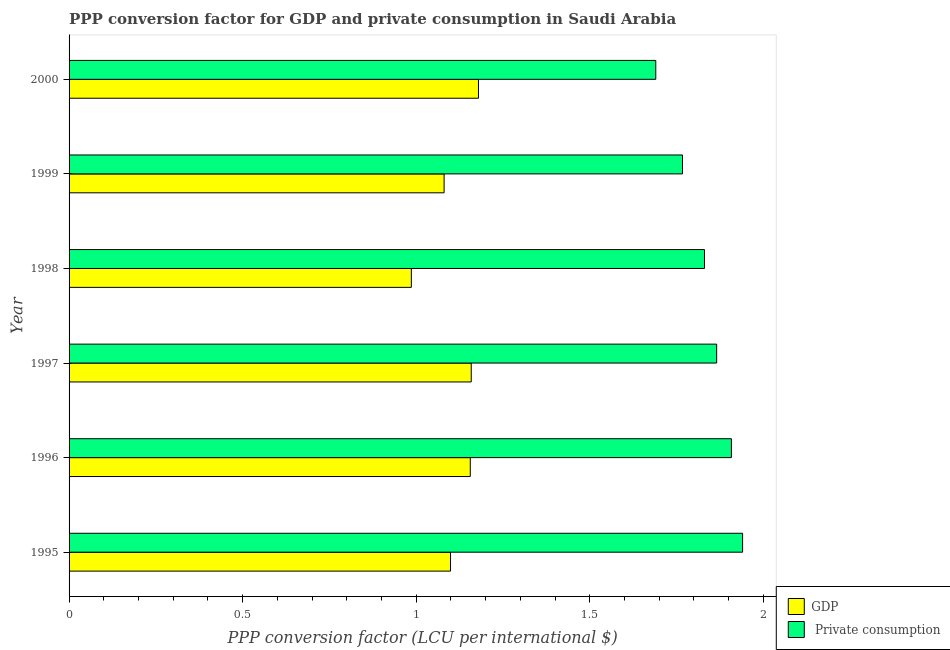How many different coloured bars are there?
Your response must be concise. 2. How many groups of bars are there?
Ensure brevity in your answer.  6. How many bars are there on the 1st tick from the bottom?
Offer a terse response. 2. What is the label of the 3rd group of bars from the top?
Offer a terse response. 1998. What is the ppp conversion factor for gdp in 1999?
Your response must be concise. 1.08. Across all years, what is the maximum ppp conversion factor for private consumption?
Make the answer very short. 1.94. Across all years, what is the minimum ppp conversion factor for gdp?
Provide a short and direct response. 0.99. What is the total ppp conversion factor for gdp in the graph?
Your answer should be very brief. 6.66. What is the difference between the ppp conversion factor for private consumption in 1996 and that in 1997?
Make the answer very short. 0.04. What is the difference between the ppp conversion factor for private consumption in 1995 and the ppp conversion factor for gdp in 2000?
Keep it short and to the point. 0.76. What is the average ppp conversion factor for private consumption per year?
Offer a terse response. 1.83. In the year 1996, what is the difference between the ppp conversion factor for private consumption and ppp conversion factor for gdp?
Ensure brevity in your answer.  0.75. What is the ratio of the ppp conversion factor for private consumption in 1995 to that in 1999?
Offer a very short reply. 1.1. Is the ppp conversion factor for gdp in 1998 less than that in 2000?
Provide a succinct answer. Yes. What is the difference between the highest and the second highest ppp conversion factor for gdp?
Your answer should be very brief. 0.02. Is the sum of the ppp conversion factor for gdp in 1995 and 1996 greater than the maximum ppp conversion factor for private consumption across all years?
Offer a very short reply. Yes. What does the 2nd bar from the top in 1998 represents?
Your answer should be compact. GDP. What does the 1st bar from the bottom in 2000 represents?
Offer a terse response. GDP. How many bars are there?
Your answer should be compact. 12. What is the difference between two consecutive major ticks on the X-axis?
Your answer should be compact. 0.5. Does the graph contain grids?
Offer a very short reply. No. Where does the legend appear in the graph?
Keep it short and to the point. Bottom right. How are the legend labels stacked?
Ensure brevity in your answer.  Vertical. What is the title of the graph?
Provide a succinct answer. PPP conversion factor for GDP and private consumption in Saudi Arabia. Does "Subsidies" appear as one of the legend labels in the graph?
Provide a succinct answer. No. What is the label or title of the X-axis?
Give a very brief answer. PPP conversion factor (LCU per international $). What is the label or title of the Y-axis?
Your answer should be compact. Year. What is the PPP conversion factor (LCU per international $) of GDP in 1995?
Provide a short and direct response. 1.1. What is the PPP conversion factor (LCU per international $) of  Private consumption in 1995?
Make the answer very short. 1.94. What is the PPP conversion factor (LCU per international $) of GDP in 1996?
Give a very brief answer. 1.16. What is the PPP conversion factor (LCU per international $) of  Private consumption in 1996?
Make the answer very short. 1.91. What is the PPP conversion factor (LCU per international $) in GDP in 1997?
Your answer should be compact. 1.16. What is the PPP conversion factor (LCU per international $) of  Private consumption in 1997?
Offer a terse response. 1.87. What is the PPP conversion factor (LCU per international $) in GDP in 1998?
Ensure brevity in your answer.  0.99. What is the PPP conversion factor (LCU per international $) in  Private consumption in 1998?
Offer a very short reply. 1.83. What is the PPP conversion factor (LCU per international $) of GDP in 1999?
Give a very brief answer. 1.08. What is the PPP conversion factor (LCU per international $) in  Private consumption in 1999?
Make the answer very short. 1.77. What is the PPP conversion factor (LCU per international $) of GDP in 2000?
Give a very brief answer. 1.18. What is the PPP conversion factor (LCU per international $) of  Private consumption in 2000?
Provide a short and direct response. 1.69. Across all years, what is the maximum PPP conversion factor (LCU per international $) of GDP?
Ensure brevity in your answer.  1.18. Across all years, what is the maximum PPP conversion factor (LCU per international $) of  Private consumption?
Your answer should be compact. 1.94. Across all years, what is the minimum PPP conversion factor (LCU per international $) in GDP?
Your answer should be very brief. 0.99. Across all years, what is the minimum PPP conversion factor (LCU per international $) in  Private consumption?
Provide a short and direct response. 1.69. What is the total PPP conversion factor (LCU per international $) of GDP in the graph?
Keep it short and to the point. 6.66. What is the total PPP conversion factor (LCU per international $) in  Private consumption in the graph?
Make the answer very short. 11. What is the difference between the PPP conversion factor (LCU per international $) in GDP in 1995 and that in 1996?
Provide a succinct answer. -0.06. What is the difference between the PPP conversion factor (LCU per international $) of  Private consumption in 1995 and that in 1996?
Give a very brief answer. 0.03. What is the difference between the PPP conversion factor (LCU per international $) in GDP in 1995 and that in 1997?
Your answer should be very brief. -0.06. What is the difference between the PPP conversion factor (LCU per international $) in  Private consumption in 1995 and that in 1997?
Provide a short and direct response. 0.07. What is the difference between the PPP conversion factor (LCU per international $) in GDP in 1995 and that in 1998?
Offer a terse response. 0.11. What is the difference between the PPP conversion factor (LCU per international $) of  Private consumption in 1995 and that in 1998?
Your response must be concise. 0.11. What is the difference between the PPP conversion factor (LCU per international $) in GDP in 1995 and that in 1999?
Offer a terse response. 0.02. What is the difference between the PPP conversion factor (LCU per international $) of  Private consumption in 1995 and that in 1999?
Keep it short and to the point. 0.17. What is the difference between the PPP conversion factor (LCU per international $) of GDP in 1995 and that in 2000?
Offer a terse response. -0.08. What is the difference between the PPP conversion factor (LCU per international $) of  Private consumption in 1995 and that in 2000?
Give a very brief answer. 0.25. What is the difference between the PPP conversion factor (LCU per international $) of GDP in 1996 and that in 1997?
Your answer should be compact. -0. What is the difference between the PPP conversion factor (LCU per international $) in  Private consumption in 1996 and that in 1997?
Offer a terse response. 0.04. What is the difference between the PPP conversion factor (LCU per international $) in GDP in 1996 and that in 1998?
Keep it short and to the point. 0.17. What is the difference between the PPP conversion factor (LCU per international $) in  Private consumption in 1996 and that in 1998?
Make the answer very short. 0.08. What is the difference between the PPP conversion factor (LCU per international $) in GDP in 1996 and that in 1999?
Ensure brevity in your answer.  0.08. What is the difference between the PPP conversion factor (LCU per international $) of  Private consumption in 1996 and that in 1999?
Make the answer very short. 0.14. What is the difference between the PPP conversion factor (LCU per international $) of GDP in 1996 and that in 2000?
Give a very brief answer. -0.02. What is the difference between the PPP conversion factor (LCU per international $) in  Private consumption in 1996 and that in 2000?
Keep it short and to the point. 0.22. What is the difference between the PPP conversion factor (LCU per international $) of GDP in 1997 and that in 1998?
Your answer should be compact. 0.17. What is the difference between the PPP conversion factor (LCU per international $) of  Private consumption in 1997 and that in 1998?
Keep it short and to the point. 0.04. What is the difference between the PPP conversion factor (LCU per international $) of GDP in 1997 and that in 1999?
Your response must be concise. 0.08. What is the difference between the PPP conversion factor (LCU per international $) in  Private consumption in 1997 and that in 1999?
Your answer should be very brief. 0.1. What is the difference between the PPP conversion factor (LCU per international $) of GDP in 1997 and that in 2000?
Keep it short and to the point. -0.02. What is the difference between the PPP conversion factor (LCU per international $) of  Private consumption in 1997 and that in 2000?
Your response must be concise. 0.18. What is the difference between the PPP conversion factor (LCU per international $) in GDP in 1998 and that in 1999?
Make the answer very short. -0.09. What is the difference between the PPP conversion factor (LCU per international $) of  Private consumption in 1998 and that in 1999?
Ensure brevity in your answer.  0.06. What is the difference between the PPP conversion factor (LCU per international $) in GDP in 1998 and that in 2000?
Give a very brief answer. -0.19. What is the difference between the PPP conversion factor (LCU per international $) of  Private consumption in 1998 and that in 2000?
Keep it short and to the point. 0.14. What is the difference between the PPP conversion factor (LCU per international $) of GDP in 1999 and that in 2000?
Give a very brief answer. -0.1. What is the difference between the PPP conversion factor (LCU per international $) in  Private consumption in 1999 and that in 2000?
Ensure brevity in your answer.  0.08. What is the difference between the PPP conversion factor (LCU per international $) of GDP in 1995 and the PPP conversion factor (LCU per international $) of  Private consumption in 1996?
Your answer should be very brief. -0.81. What is the difference between the PPP conversion factor (LCU per international $) in GDP in 1995 and the PPP conversion factor (LCU per international $) in  Private consumption in 1997?
Your answer should be very brief. -0.77. What is the difference between the PPP conversion factor (LCU per international $) in GDP in 1995 and the PPP conversion factor (LCU per international $) in  Private consumption in 1998?
Keep it short and to the point. -0.73. What is the difference between the PPP conversion factor (LCU per international $) in GDP in 1995 and the PPP conversion factor (LCU per international $) in  Private consumption in 1999?
Provide a succinct answer. -0.67. What is the difference between the PPP conversion factor (LCU per international $) of GDP in 1995 and the PPP conversion factor (LCU per international $) of  Private consumption in 2000?
Give a very brief answer. -0.59. What is the difference between the PPP conversion factor (LCU per international $) of GDP in 1996 and the PPP conversion factor (LCU per international $) of  Private consumption in 1997?
Provide a short and direct response. -0.71. What is the difference between the PPP conversion factor (LCU per international $) in GDP in 1996 and the PPP conversion factor (LCU per international $) in  Private consumption in 1998?
Your answer should be very brief. -0.67. What is the difference between the PPP conversion factor (LCU per international $) in GDP in 1996 and the PPP conversion factor (LCU per international $) in  Private consumption in 1999?
Provide a short and direct response. -0.61. What is the difference between the PPP conversion factor (LCU per international $) in GDP in 1996 and the PPP conversion factor (LCU per international $) in  Private consumption in 2000?
Your answer should be very brief. -0.53. What is the difference between the PPP conversion factor (LCU per international $) of GDP in 1997 and the PPP conversion factor (LCU per international $) of  Private consumption in 1998?
Offer a very short reply. -0.67. What is the difference between the PPP conversion factor (LCU per international $) of GDP in 1997 and the PPP conversion factor (LCU per international $) of  Private consumption in 1999?
Ensure brevity in your answer.  -0.61. What is the difference between the PPP conversion factor (LCU per international $) in GDP in 1997 and the PPP conversion factor (LCU per international $) in  Private consumption in 2000?
Give a very brief answer. -0.53. What is the difference between the PPP conversion factor (LCU per international $) in GDP in 1998 and the PPP conversion factor (LCU per international $) in  Private consumption in 1999?
Make the answer very short. -0.78. What is the difference between the PPP conversion factor (LCU per international $) in GDP in 1998 and the PPP conversion factor (LCU per international $) in  Private consumption in 2000?
Your response must be concise. -0.7. What is the difference between the PPP conversion factor (LCU per international $) of GDP in 1999 and the PPP conversion factor (LCU per international $) of  Private consumption in 2000?
Provide a short and direct response. -0.61. What is the average PPP conversion factor (LCU per international $) of GDP per year?
Your answer should be very brief. 1.11. What is the average PPP conversion factor (LCU per international $) of  Private consumption per year?
Your response must be concise. 1.83. In the year 1995, what is the difference between the PPP conversion factor (LCU per international $) in GDP and PPP conversion factor (LCU per international $) in  Private consumption?
Provide a succinct answer. -0.84. In the year 1996, what is the difference between the PPP conversion factor (LCU per international $) of GDP and PPP conversion factor (LCU per international $) of  Private consumption?
Keep it short and to the point. -0.75. In the year 1997, what is the difference between the PPP conversion factor (LCU per international $) of GDP and PPP conversion factor (LCU per international $) of  Private consumption?
Offer a terse response. -0.71. In the year 1998, what is the difference between the PPP conversion factor (LCU per international $) in GDP and PPP conversion factor (LCU per international $) in  Private consumption?
Provide a succinct answer. -0.84. In the year 1999, what is the difference between the PPP conversion factor (LCU per international $) in GDP and PPP conversion factor (LCU per international $) in  Private consumption?
Offer a terse response. -0.69. In the year 2000, what is the difference between the PPP conversion factor (LCU per international $) of GDP and PPP conversion factor (LCU per international $) of  Private consumption?
Offer a very short reply. -0.51. What is the ratio of the PPP conversion factor (LCU per international $) in GDP in 1995 to that in 1996?
Your answer should be very brief. 0.95. What is the ratio of the PPP conversion factor (LCU per international $) of  Private consumption in 1995 to that in 1996?
Your response must be concise. 1.02. What is the ratio of the PPP conversion factor (LCU per international $) of GDP in 1995 to that in 1997?
Give a very brief answer. 0.95. What is the ratio of the PPP conversion factor (LCU per international $) of  Private consumption in 1995 to that in 1997?
Give a very brief answer. 1.04. What is the ratio of the PPP conversion factor (LCU per international $) in GDP in 1995 to that in 1998?
Give a very brief answer. 1.11. What is the ratio of the PPP conversion factor (LCU per international $) in  Private consumption in 1995 to that in 1998?
Your response must be concise. 1.06. What is the ratio of the PPP conversion factor (LCU per international $) in GDP in 1995 to that in 1999?
Offer a very short reply. 1.02. What is the ratio of the PPP conversion factor (LCU per international $) in  Private consumption in 1995 to that in 1999?
Offer a terse response. 1.1. What is the ratio of the PPP conversion factor (LCU per international $) of GDP in 1995 to that in 2000?
Give a very brief answer. 0.93. What is the ratio of the PPP conversion factor (LCU per international $) in  Private consumption in 1995 to that in 2000?
Your response must be concise. 1.15. What is the ratio of the PPP conversion factor (LCU per international $) of  Private consumption in 1996 to that in 1997?
Give a very brief answer. 1.02. What is the ratio of the PPP conversion factor (LCU per international $) of GDP in 1996 to that in 1998?
Offer a very short reply. 1.17. What is the ratio of the PPP conversion factor (LCU per international $) of  Private consumption in 1996 to that in 1998?
Provide a succinct answer. 1.04. What is the ratio of the PPP conversion factor (LCU per international $) in GDP in 1996 to that in 1999?
Provide a short and direct response. 1.07. What is the ratio of the PPP conversion factor (LCU per international $) of  Private consumption in 1996 to that in 1999?
Provide a short and direct response. 1.08. What is the ratio of the PPP conversion factor (LCU per international $) of  Private consumption in 1996 to that in 2000?
Your response must be concise. 1.13. What is the ratio of the PPP conversion factor (LCU per international $) in GDP in 1997 to that in 1998?
Offer a very short reply. 1.18. What is the ratio of the PPP conversion factor (LCU per international $) of  Private consumption in 1997 to that in 1998?
Make the answer very short. 1.02. What is the ratio of the PPP conversion factor (LCU per international $) in GDP in 1997 to that in 1999?
Your answer should be compact. 1.07. What is the ratio of the PPP conversion factor (LCU per international $) in  Private consumption in 1997 to that in 1999?
Offer a terse response. 1.06. What is the ratio of the PPP conversion factor (LCU per international $) of GDP in 1997 to that in 2000?
Provide a succinct answer. 0.98. What is the ratio of the PPP conversion factor (LCU per international $) of  Private consumption in 1997 to that in 2000?
Provide a short and direct response. 1.1. What is the ratio of the PPP conversion factor (LCU per international $) of GDP in 1998 to that in 1999?
Your answer should be compact. 0.91. What is the ratio of the PPP conversion factor (LCU per international $) of  Private consumption in 1998 to that in 1999?
Your response must be concise. 1.04. What is the ratio of the PPP conversion factor (LCU per international $) in GDP in 1998 to that in 2000?
Provide a succinct answer. 0.84. What is the ratio of the PPP conversion factor (LCU per international $) in  Private consumption in 1998 to that in 2000?
Give a very brief answer. 1.08. What is the ratio of the PPP conversion factor (LCU per international $) in GDP in 1999 to that in 2000?
Provide a succinct answer. 0.92. What is the ratio of the PPP conversion factor (LCU per international $) in  Private consumption in 1999 to that in 2000?
Your answer should be very brief. 1.05. What is the difference between the highest and the second highest PPP conversion factor (LCU per international $) of GDP?
Provide a short and direct response. 0.02. What is the difference between the highest and the second highest PPP conversion factor (LCU per international $) in  Private consumption?
Your response must be concise. 0.03. What is the difference between the highest and the lowest PPP conversion factor (LCU per international $) in GDP?
Keep it short and to the point. 0.19. What is the difference between the highest and the lowest PPP conversion factor (LCU per international $) of  Private consumption?
Provide a short and direct response. 0.25. 